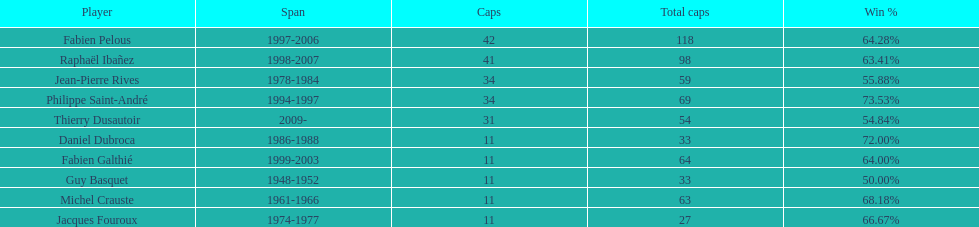How long did fabien pelous serve as captain in the french national rugby team? 9 years. 